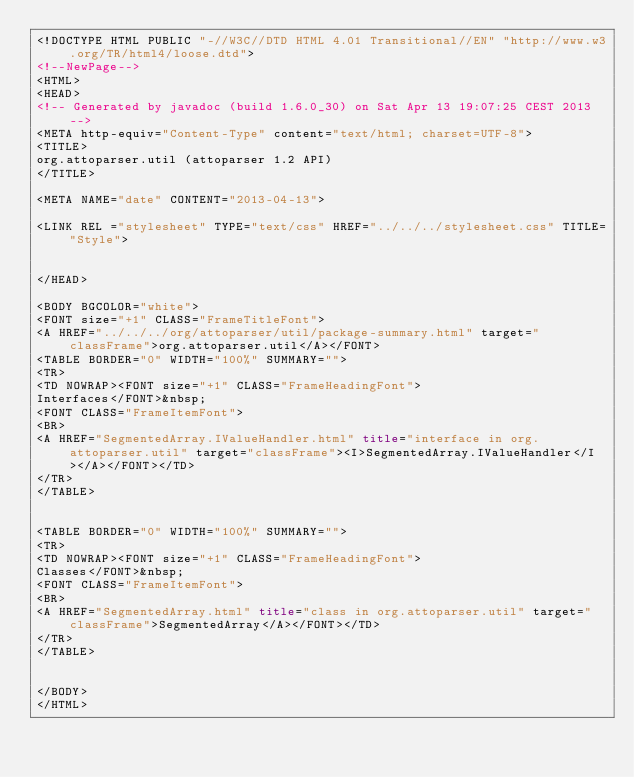<code> <loc_0><loc_0><loc_500><loc_500><_HTML_><!DOCTYPE HTML PUBLIC "-//W3C//DTD HTML 4.01 Transitional//EN" "http://www.w3.org/TR/html4/loose.dtd">
<!--NewPage-->
<HTML>
<HEAD>
<!-- Generated by javadoc (build 1.6.0_30) on Sat Apr 13 19:07:25 CEST 2013 -->
<META http-equiv="Content-Type" content="text/html; charset=UTF-8">
<TITLE>
org.attoparser.util (attoparser 1.2 API)
</TITLE>

<META NAME="date" CONTENT="2013-04-13">

<LINK REL ="stylesheet" TYPE="text/css" HREF="../../../stylesheet.css" TITLE="Style">


</HEAD>

<BODY BGCOLOR="white">
<FONT size="+1" CLASS="FrameTitleFont">
<A HREF="../../../org/attoparser/util/package-summary.html" target="classFrame">org.attoparser.util</A></FONT>
<TABLE BORDER="0" WIDTH="100%" SUMMARY="">
<TR>
<TD NOWRAP><FONT size="+1" CLASS="FrameHeadingFont">
Interfaces</FONT>&nbsp;
<FONT CLASS="FrameItemFont">
<BR>
<A HREF="SegmentedArray.IValueHandler.html" title="interface in org.attoparser.util" target="classFrame"><I>SegmentedArray.IValueHandler</I></A></FONT></TD>
</TR>
</TABLE>


<TABLE BORDER="0" WIDTH="100%" SUMMARY="">
<TR>
<TD NOWRAP><FONT size="+1" CLASS="FrameHeadingFont">
Classes</FONT>&nbsp;
<FONT CLASS="FrameItemFont">
<BR>
<A HREF="SegmentedArray.html" title="class in org.attoparser.util" target="classFrame">SegmentedArray</A></FONT></TD>
</TR>
</TABLE>


</BODY>
</HTML>
</code> 